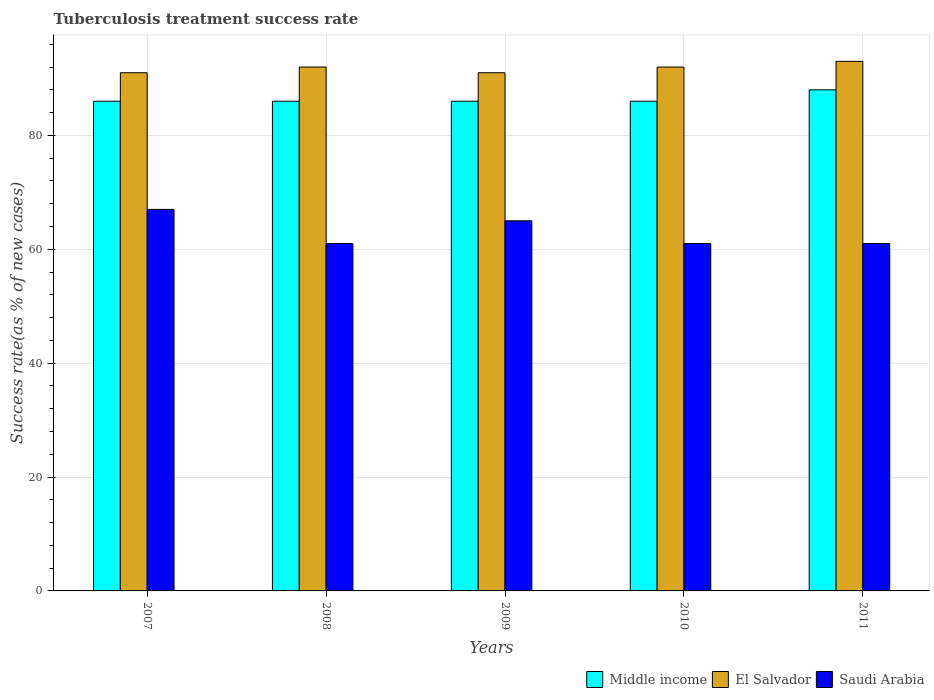How many different coloured bars are there?
Offer a very short reply. 3. How many groups of bars are there?
Your answer should be very brief. 5. Are the number of bars per tick equal to the number of legend labels?
Ensure brevity in your answer.  Yes. Are the number of bars on each tick of the X-axis equal?
Keep it short and to the point. Yes. How many bars are there on the 3rd tick from the right?
Offer a terse response. 3. What is the label of the 3rd group of bars from the left?
Keep it short and to the point. 2009. In how many cases, is the number of bars for a given year not equal to the number of legend labels?
Keep it short and to the point. 0. Across all years, what is the maximum tuberculosis treatment success rate in El Salvador?
Provide a short and direct response. 93. Across all years, what is the minimum tuberculosis treatment success rate in El Salvador?
Keep it short and to the point. 91. In which year was the tuberculosis treatment success rate in Middle income minimum?
Your response must be concise. 2007. What is the total tuberculosis treatment success rate in Saudi Arabia in the graph?
Offer a very short reply. 315. What is the difference between the tuberculosis treatment success rate in El Salvador in 2007 and that in 2010?
Offer a very short reply. -1. What is the difference between the tuberculosis treatment success rate in Middle income in 2011 and the tuberculosis treatment success rate in El Salvador in 2009?
Your response must be concise. -3. What is the average tuberculosis treatment success rate in Saudi Arabia per year?
Give a very brief answer. 63. What is the ratio of the tuberculosis treatment success rate in Saudi Arabia in 2009 to that in 2010?
Make the answer very short. 1.07. Is the difference between the tuberculosis treatment success rate in Saudi Arabia in 2008 and 2011 greater than the difference between the tuberculosis treatment success rate in El Salvador in 2008 and 2011?
Provide a succinct answer. Yes. What is the difference between the highest and the second highest tuberculosis treatment success rate in Saudi Arabia?
Ensure brevity in your answer.  2. What is the difference between the highest and the lowest tuberculosis treatment success rate in El Salvador?
Your answer should be compact. 2. In how many years, is the tuberculosis treatment success rate in Middle income greater than the average tuberculosis treatment success rate in Middle income taken over all years?
Offer a very short reply. 1. Is the sum of the tuberculosis treatment success rate in Middle income in 2008 and 2011 greater than the maximum tuberculosis treatment success rate in Saudi Arabia across all years?
Offer a terse response. Yes. What does the 3rd bar from the left in 2011 represents?
Keep it short and to the point. Saudi Arabia. What does the 3rd bar from the right in 2009 represents?
Offer a very short reply. Middle income. How many bars are there?
Provide a succinct answer. 15. Are all the bars in the graph horizontal?
Offer a very short reply. No. Are the values on the major ticks of Y-axis written in scientific E-notation?
Your response must be concise. No. How are the legend labels stacked?
Ensure brevity in your answer.  Horizontal. What is the title of the graph?
Offer a terse response. Tuberculosis treatment success rate. Does "Hungary" appear as one of the legend labels in the graph?
Keep it short and to the point. No. What is the label or title of the X-axis?
Make the answer very short. Years. What is the label or title of the Y-axis?
Provide a short and direct response. Success rate(as % of new cases). What is the Success rate(as % of new cases) of Middle income in 2007?
Your answer should be very brief. 86. What is the Success rate(as % of new cases) of El Salvador in 2007?
Give a very brief answer. 91. What is the Success rate(as % of new cases) in Saudi Arabia in 2007?
Your answer should be compact. 67. What is the Success rate(as % of new cases) of Middle income in 2008?
Provide a short and direct response. 86. What is the Success rate(as % of new cases) of El Salvador in 2008?
Give a very brief answer. 92. What is the Success rate(as % of new cases) of Saudi Arabia in 2008?
Your response must be concise. 61. What is the Success rate(as % of new cases) in El Salvador in 2009?
Your answer should be compact. 91. What is the Success rate(as % of new cases) in Saudi Arabia in 2009?
Your answer should be very brief. 65. What is the Success rate(as % of new cases) in Middle income in 2010?
Make the answer very short. 86. What is the Success rate(as % of new cases) in El Salvador in 2010?
Offer a terse response. 92. What is the Success rate(as % of new cases) in Saudi Arabia in 2010?
Make the answer very short. 61. What is the Success rate(as % of new cases) in Middle income in 2011?
Keep it short and to the point. 88. What is the Success rate(as % of new cases) of El Salvador in 2011?
Provide a short and direct response. 93. What is the Success rate(as % of new cases) of Saudi Arabia in 2011?
Offer a very short reply. 61. Across all years, what is the maximum Success rate(as % of new cases) of Middle income?
Provide a short and direct response. 88. Across all years, what is the maximum Success rate(as % of new cases) in El Salvador?
Provide a short and direct response. 93. Across all years, what is the minimum Success rate(as % of new cases) in El Salvador?
Offer a terse response. 91. Across all years, what is the minimum Success rate(as % of new cases) of Saudi Arabia?
Your answer should be compact. 61. What is the total Success rate(as % of new cases) of Middle income in the graph?
Your answer should be very brief. 432. What is the total Success rate(as % of new cases) of El Salvador in the graph?
Your answer should be very brief. 459. What is the total Success rate(as % of new cases) in Saudi Arabia in the graph?
Ensure brevity in your answer.  315. What is the difference between the Success rate(as % of new cases) of Middle income in 2007 and that in 2008?
Your answer should be compact. 0. What is the difference between the Success rate(as % of new cases) of El Salvador in 2007 and that in 2008?
Keep it short and to the point. -1. What is the difference between the Success rate(as % of new cases) in Saudi Arabia in 2007 and that in 2008?
Your response must be concise. 6. What is the difference between the Success rate(as % of new cases) in Middle income in 2007 and that in 2009?
Offer a very short reply. 0. What is the difference between the Success rate(as % of new cases) of El Salvador in 2007 and that in 2009?
Provide a short and direct response. 0. What is the difference between the Success rate(as % of new cases) in Saudi Arabia in 2007 and that in 2009?
Keep it short and to the point. 2. What is the difference between the Success rate(as % of new cases) of Saudi Arabia in 2007 and that in 2010?
Provide a short and direct response. 6. What is the difference between the Success rate(as % of new cases) of Saudi Arabia in 2007 and that in 2011?
Your answer should be compact. 6. What is the difference between the Success rate(as % of new cases) of Saudi Arabia in 2008 and that in 2009?
Offer a very short reply. -4. What is the difference between the Success rate(as % of new cases) in El Salvador in 2008 and that in 2010?
Your answer should be very brief. 0. What is the difference between the Success rate(as % of new cases) of Saudi Arabia in 2008 and that in 2010?
Keep it short and to the point. 0. What is the difference between the Success rate(as % of new cases) in Middle income in 2008 and that in 2011?
Keep it short and to the point. -2. What is the difference between the Success rate(as % of new cases) in El Salvador in 2008 and that in 2011?
Make the answer very short. -1. What is the difference between the Success rate(as % of new cases) of Saudi Arabia in 2008 and that in 2011?
Offer a very short reply. 0. What is the difference between the Success rate(as % of new cases) in El Salvador in 2009 and that in 2010?
Your response must be concise. -1. What is the difference between the Success rate(as % of new cases) of Saudi Arabia in 2009 and that in 2010?
Your response must be concise. 4. What is the difference between the Success rate(as % of new cases) in Middle income in 2009 and that in 2011?
Provide a short and direct response. -2. What is the difference between the Success rate(as % of new cases) of El Salvador in 2009 and that in 2011?
Your answer should be very brief. -2. What is the difference between the Success rate(as % of new cases) of El Salvador in 2010 and that in 2011?
Make the answer very short. -1. What is the difference between the Success rate(as % of new cases) of Saudi Arabia in 2010 and that in 2011?
Ensure brevity in your answer.  0. What is the difference between the Success rate(as % of new cases) of Middle income in 2007 and the Success rate(as % of new cases) of Saudi Arabia in 2008?
Offer a terse response. 25. What is the difference between the Success rate(as % of new cases) in El Salvador in 2007 and the Success rate(as % of new cases) in Saudi Arabia in 2008?
Make the answer very short. 30. What is the difference between the Success rate(as % of new cases) in Middle income in 2007 and the Success rate(as % of new cases) in El Salvador in 2009?
Make the answer very short. -5. What is the difference between the Success rate(as % of new cases) of Middle income in 2007 and the Success rate(as % of new cases) of Saudi Arabia in 2009?
Provide a succinct answer. 21. What is the difference between the Success rate(as % of new cases) in El Salvador in 2007 and the Success rate(as % of new cases) in Saudi Arabia in 2009?
Provide a short and direct response. 26. What is the difference between the Success rate(as % of new cases) in Middle income in 2007 and the Success rate(as % of new cases) in El Salvador in 2010?
Keep it short and to the point. -6. What is the difference between the Success rate(as % of new cases) in El Salvador in 2007 and the Success rate(as % of new cases) in Saudi Arabia in 2010?
Ensure brevity in your answer.  30. What is the difference between the Success rate(as % of new cases) of Middle income in 2007 and the Success rate(as % of new cases) of Saudi Arabia in 2011?
Ensure brevity in your answer.  25. What is the difference between the Success rate(as % of new cases) of El Salvador in 2007 and the Success rate(as % of new cases) of Saudi Arabia in 2011?
Give a very brief answer. 30. What is the difference between the Success rate(as % of new cases) in Middle income in 2008 and the Success rate(as % of new cases) in El Salvador in 2009?
Provide a succinct answer. -5. What is the difference between the Success rate(as % of new cases) in Middle income in 2008 and the Success rate(as % of new cases) in Saudi Arabia in 2009?
Your answer should be very brief. 21. What is the difference between the Success rate(as % of new cases) in El Salvador in 2008 and the Success rate(as % of new cases) in Saudi Arabia in 2009?
Offer a terse response. 27. What is the difference between the Success rate(as % of new cases) of El Salvador in 2008 and the Success rate(as % of new cases) of Saudi Arabia in 2010?
Provide a short and direct response. 31. What is the difference between the Success rate(as % of new cases) in Middle income in 2008 and the Success rate(as % of new cases) in El Salvador in 2011?
Keep it short and to the point. -7. What is the difference between the Success rate(as % of new cases) of Middle income in 2008 and the Success rate(as % of new cases) of Saudi Arabia in 2011?
Your response must be concise. 25. What is the difference between the Success rate(as % of new cases) in El Salvador in 2008 and the Success rate(as % of new cases) in Saudi Arabia in 2011?
Keep it short and to the point. 31. What is the difference between the Success rate(as % of new cases) in El Salvador in 2009 and the Success rate(as % of new cases) in Saudi Arabia in 2010?
Give a very brief answer. 30. What is the difference between the Success rate(as % of new cases) of Middle income in 2009 and the Success rate(as % of new cases) of El Salvador in 2011?
Provide a short and direct response. -7. What is the difference between the Success rate(as % of new cases) of El Salvador in 2009 and the Success rate(as % of new cases) of Saudi Arabia in 2011?
Provide a succinct answer. 30. What is the difference between the Success rate(as % of new cases) in Middle income in 2010 and the Success rate(as % of new cases) in El Salvador in 2011?
Your answer should be compact. -7. What is the average Success rate(as % of new cases) of Middle income per year?
Offer a very short reply. 86.4. What is the average Success rate(as % of new cases) in El Salvador per year?
Your response must be concise. 91.8. In the year 2007, what is the difference between the Success rate(as % of new cases) in Middle income and Success rate(as % of new cases) in Saudi Arabia?
Keep it short and to the point. 19. In the year 2007, what is the difference between the Success rate(as % of new cases) of El Salvador and Success rate(as % of new cases) of Saudi Arabia?
Your answer should be very brief. 24. In the year 2008, what is the difference between the Success rate(as % of new cases) of Middle income and Success rate(as % of new cases) of El Salvador?
Offer a terse response. -6. In the year 2008, what is the difference between the Success rate(as % of new cases) of Middle income and Success rate(as % of new cases) of Saudi Arabia?
Your answer should be compact. 25. In the year 2009, what is the difference between the Success rate(as % of new cases) in Middle income and Success rate(as % of new cases) in El Salvador?
Ensure brevity in your answer.  -5. In the year 2009, what is the difference between the Success rate(as % of new cases) in El Salvador and Success rate(as % of new cases) in Saudi Arabia?
Give a very brief answer. 26. In the year 2010, what is the difference between the Success rate(as % of new cases) in Middle income and Success rate(as % of new cases) in El Salvador?
Give a very brief answer. -6. In the year 2011, what is the difference between the Success rate(as % of new cases) in Middle income and Success rate(as % of new cases) in El Salvador?
Your answer should be very brief. -5. In the year 2011, what is the difference between the Success rate(as % of new cases) in Middle income and Success rate(as % of new cases) in Saudi Arabia?
Give a very brief answer. 27. In the year 2011, what is the difference between the Success rate(as % of new cases) of El Salvador and Success rate(as % of new cases) of Saudi Arabia?
Give a very brief answer. 32. What is the ratio of the Success rate(as % of new cases) in El Salvador in 2007 to that in 2008?
Ensure brevity in your answer.  0.99. What is the ratio of the Success rate(as % of new cases) in Saudi Arabia in 2007 to that in 2008?
Provide a short and direct response. 1.1. What is the ratio of the Success rate(as % of new cases) of Saudi Arabia in 2007 to that in 2009?
Your answer should be very brief. 1.03. What is the ratio of the Success rate(as % of new cases) in Middle income in 2007 to that in 2010?
Offer a terse response. 1. What is the ratio of the Success rate(as % of new cases) in Saudi Arabia in 2007 to that in 2010?
Your response must be concise. 1.1. What is the ratio of the Success rate(as % of new cases) in Middle income in 2007 to that in 2011?
Offer a very short reply. 0.98. What is the ratio of the Success rate(as % of new cases) in El Salvador in 2007 to that in 2011?
Offer a terse response. 0.98. What is the ratio of the Success rate(as % of new cases) of Saudi Arabia in 2007 to that in 2011?
Your answer should be compact. 1.1. What is the ratio of the Success rate(as % of new cases) of Middle income in 2008 to that in 2009?
Provide a succinct answer. 1. What is the ratio of the Success rate(as % of new cases) in El Salvador in 2008 to that in 2009?
Provide a succinct answer. 1.01. What is the ratio of the Success rate(as % of new cases) in Saudi Arabia in 2008 to that in 2009?
Offer a terse response. 0.94. What is the ratio of the Success rate(as % of new cases) in Middle income in 2008 to that in 2011?
Your answer should be compact. 0.98. What is the ratio of the Success rate(as % of new cases) in El Salvador in 2008 to that in 2011?
Your response must be concise. 0.99. What is the ratio of the Success rate(as % of new cases) in Saudi Arabia in 2008 to that in 2011?
Keep it short and to the point. 1. What is the ratio of the Success rate(as % of new cases) of Middle income in 2009 to that in 2010?
Provide a short and direct response. 1. What is the ratio of the Success rate(as % of new cases) of El Salvador in 2009 to that in 2010?
Give a very brief answer. 0.99. What is the ratio of the Success rate(as % of new cases) in Saudi Arabia in 2009 to that in 2010?
Ensure brevity in your answer.  1.07. What is the ratio of the Success rate(as % of new cases) of Middle income in 2009 to that in 2011?
Provide a succinct answer. 0.98. What is the ratio of the Success rate(as % of new cases) of El Salvador in 2009 to that in 2011?
Ensure brevity in your answer.  0.98. What is the ratio of the Success rate(as % of new cases) of Saudi Arabia in 2009 to that in 2011?
Offer a very short reply. 1.07. What is the ratio of the Success rate(as % of new cases) in Middle income in 2010 to that in 2011?
Give a very brief answer. 0.98. What is the difference between the highest and the second highest Success rate(as % of new cases) of El Salvador?
Your answer should be compact. 1. What is the difference between the highest and the second highest Success rate(as % of new cases) of Saudi Arabia?
Make the answer very short. 2. What is the difference between the highest and the lowest Success rate(as % of new cases) of Middle income?
Your response must be concise. 2. 